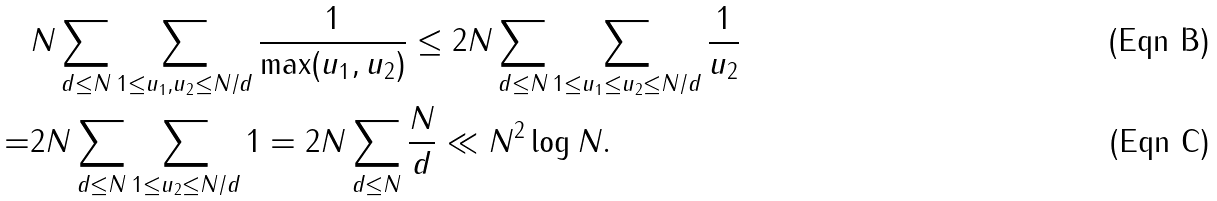Convert formula to latex. <formula><loc_0><loc_0><loc_500><loc_500>& N \sum _ { d \leq N } \sum _ { 1 \leq u _ { 1 } , u _ { 2 } \leq N / d } \frac { 1 } { \max ( u _ { 1 } , u _ { 2 } ) } \leq 2 N \sum _ { d \leq N } \sum _ { 1 \leq u _ { 1 } \leq u _ { 2 } \leq N / d } \frac { 1 } { u _ { 2 } } \\ = & 2 N \sum _ { d \leq N } \sum _ { 1 \leq u _ { 2 } \leq N / d } 1 = 2 N \sum _ { d \leq N } \frac { N } { d } \ll N ^ { 2 } \log N .</formula> 